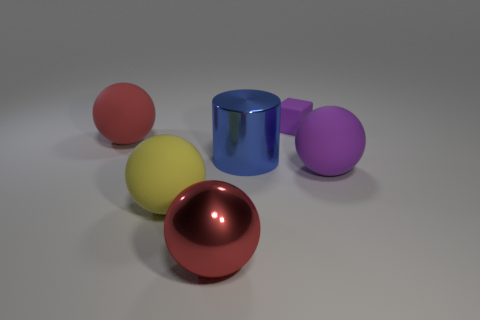Can you describe the lighting in the image and its effect on the objects? The lighting in the image is soft and diffuse, casting gentle shadows that anchor the objects onto the surface and give them form and volume. The light appears to be coming from the upper left side, as indicated by the shadows being to the lower right of each object. This lighting style contributes to a calm and balanced atmosphere within the image. 